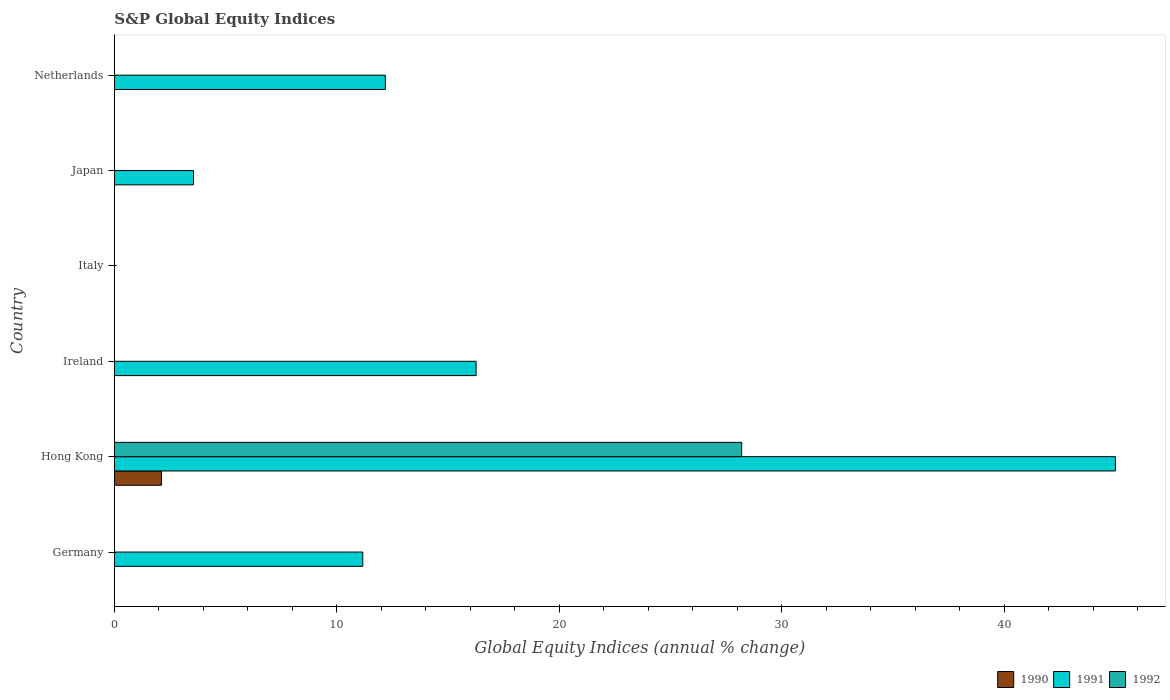How many different coloured bars are there?
Provide a succinct answer. 3. Are the number of bars on each tick of the Y-axis equal?
Offer a very short reply. No. How many bars are there on the 4th tick from the bottom?
Ensure brevity in your answer.  0. What is the label of the 5th group of bars from the top?
Your answer should be compact. Hong Kong. What is the global equity indices in 1992 in Japan?
Provide a succinct answer. 0. Across all countries, what is the maximum global equity indices in 1990?
Your answer should be compact. 2.11. In which country was the global equity indices in 1990 maximum?
Your answer should be very brief. Hong Kong. What is the total global equity indices in 1991 in the graph?
Keep it short and to the point. 88.14. What is the difference between the global equity indices in 1991 in Germany and that in Japan?
Keep it short and to the point. 7.61. What is the average global equity indices in 1992 per country?
Your response must be concise. 4.7. What is the difference between the global equity indices in 1992 and global equity indices in 1991 in Hong Kong?
Your answer should be very brief. -16.8. What is the difference between the highest and the second highest global equity indices in 1991?
Offer a terse response. 28.74. What is the difference between the highest and the lowest global equity indices in 1991?
Give a very brief answer. 44.99. Is the sum of the global equity indices in 1991 in Germany and Netherlands greater than the maximum global equity indices in 1990 across all countries?
Offer a terse response. Yes. Is it the case that in every country, the sum of the global equity indices in 1992 and global equity indices in 1990 is greater than the global equity indices in 1991?
Give a very brief answer. No. What is the difference between two consecutive major ticks on the X-axis?
Your response must be concise. 10. Are the values on the major ticks of X-axis written in scientific E-notation?
Your answer should be compact. No. Does the graph contain grids?
Make the answer very short. No. Where does the legend appear in the graph?
Offer a very short reply. Bottom right. How are the legend labels stacked?
Offer a terse response. Horizontal. What is the title of the graph?
Give a very brief answer. S&P Global Equity Indices. Does "2005" appear as one of the legend labels in the graph?
Provide a short and direct response. No. What is the label or title of the X-axis?
Offer a terse response. Global Equity Indices (annual % change). What is the Global Equity Indices (annual % change) in 1991 in Germany?
Make the answer very short. 11.16. What is the Global Equity Indices (annual % change) in 1990 in Hong Kong?
Provide a succinct answer. 2.11. What is the Global Equity Indices (annual % change) of 1991 in Hong Kong?
Offer a terse response. 44.99. What is the Global Equity Indices (annual % change) of 1992 in Hong Kong?
Provide a succinct answer. 28.19. What is the Global Equity Indices (annual % change) of 1990 in Ireland?
Your answer should be compact. 0. What is the Global Equity Indices (annual % change) of 1991 in Ireland?
Your answer should be compact. 16.26. What is the Global Equity Indices (annual % change) of 1992 in Ireland?
Offer a very short reply. 0. What is the Global Equity Indices (annual % change) of 1991 in Japan?
Offer a terse response. 3.55. What is the Global Equity Indices (annual % change) in 1992 in Japan?
Offer a terse response. 0. What is the Global Equity Indices (annual % change) in 1991 in Netherlands?
Your answer should be compact. 12.18. Across all countries, what is the maximum Global Equity Indices (annual % change) in 1990?
Give a very brief answer. 2.11. Across all countries, what is the maximum Global Equity Indices (annual % change) of 1991?
Your response must be concise. 44.99. Across all countries, what is the maximum Global Equity Indices (annual % change) of 1992?
Offer a very short reply. 28.19. Across all countries, what is the minimum Global Equity Indices (annual % change) of 1991?
Ensure brevity in your answer.  0. What is the total Global Equity Indices (annual % change) of 1990 in the graph?
Your answer should be very brief. 2.11. What is the total Global Equity Indices (annual % change) in 1991 in the graph?
Your answer should be compact. 88.14. What is the total Global Equity Indices (annual % change) of 1992 in the graph?
Provide a succinct answer. 28.19. What is the difference between the Global Equity Indices (annual % change) in 1991 in Germany and that in Hong Kong?
Your response must be concise. -33.83. What is the difference between the Global Equity Indices (annual % change) in 1991 in Germany and that in Ireland?
Provide a succinct answer. -5.09. What is the difference between the Global Equity Indices (annual % change) of 1991 in Germany and that in Japan?
Provide a short and direct response. 7.61. What is the difference between the Global Equity Indices (annual % change) in 1991 in Germany and that in Netherlands?
Make the answer very short. -1.01. What is the difference between the Global Equity Indices (annual % change) of 1991 in Hong Kong and that in Ireland?
Offer a very short reply. 28.74. What is the difference between the Global Equity Indices (annual % change) of 1991 in Hong Kong and that in Japan?
Your answer should be very brief. 41.44. What is the difference between the Global Equity Indices (annual % change) of 1991 in Hong Kong and that in Netherlands?
Give a very brief answer. 32.82. What is the difference between the Global Equity Indices (annual % change) in 1991 in Ireland and that in Japan?
Your answer should be very brief. 12.7. What is the difference between the Global Equity Indices (annual % change) of 1991 in Ireland and that in Netherlands?
Provide a succinct answer. 4.08. What is the difference between the Global Equity Indices (annual % change) in 1991 in Japan and that in Netherlands?
Keep it short and to the point. -8.62. What is the difference between the Global Equity Indices (annual % change) in 1991 in Germany and the Global Equity Indices (annual % change) in 1992 in Hong Kong?
Offer a very short reply. -17.03. What is the difference between the Global Equity Indices (annual % change) in 1990 in Hong Kong and the Global Equity Indices (annual % change) in 1991 in Ireland?
Your answer should be compact. -14.14. What is the difference between the Global Equity Indices (annual % change) in 1990 in Hong Kong and the Global Equity Indices (annual % change) in 1991 in Japan?
Provide a short and direct response. -1.44. What is the difference between the Global Equity Indices (annual % change) in 1990 in Hong Kong and the Global Equity Indices (annual % change) in 1991 in Netherlands?
Your response must be concise. -10.06. What is the average Global Equity Indices (annual % change) in 1990 per country?
Your response must be concise. 0.35. What is the average Global Equity Indices (annual % change) in 1991 per country?
Offer a very short reply. 14.69. What is the average Global Equity Indices (annual % change) of 1992 per country?
Your answer should be very brief. 4.7. What is the difference between the Global Equity Indices (annual % change) in 1990 and Global Equity Indices (annual % change) in 1991 in Hong Kong?
Your answer should be very brief. -42.88. What is the difference between the Global Equity Indices (annual % change) of 1990 and Global Equity Indices (annual % change) of 1992 in Hong Kong?
Make the answer very short. -26.08. What is the difference between the Global Equity Indices (annual % change) in 1991 and Global Equity Indices (annual % change) in 1992 in Hong Kong?
Ensure brevity in your answer.  16.8. What is the ratio of the Global Equity Indices (annual % change) of 1991 in Germany to that in Hong Kong?
Keep it short and to the point. 0.25. What is the ratio of the Global Equity Indices (annual % change) of 1991 in Germany to that in Ireland?
Make the answer very short. 0.69. What is the ratio of the Global Equity Indices (annual % change) in 1991 in Germany to that in Japan?
Offer a terse response. 3.14. What is the ratio of the Global Equity Indices (annual % change) of 1991 in Germany to that in Netherlands?
Provide a succinct answer. 0.92. What is the ratio of the Global Equity Indices (annual % change) in 1991 in Hong Kong to that in Ireland?
Your response must be concise. 2.77. What is the ratio of the Global Equity Indices (annual % change) of 1991 in Hong Kong to that in Japan?
Provide a short and direct response. 12.66. What is the ratio of the Global Equity Indices (annual % change) in 1991 in Hong Kong to that in Netherlands?
Ensure brevity in your answer.  3.69. What is the ratio of the Global Equity Indices (annual % change) in 1991 in Ireland to that in Japan?
Offer a terse response. 4.57. What is the ratio of the Global Equity Indices (annual % change) in 1991 in Ireland to that in Netherlands?
Your answer should be compact. 1.34. What is the ratio of the Global Equity Indices (annual % change) of 1991 in Japan to that in Netherlands?
Offer a very short reply. 0.29. What is the difference between the highest and the second highest Global Equity Indices (annual % change) of 1991?
Give a very brief answer. 28.74. What is the difference between the highest and the lowest Global Equity Indices (annual % change) of 1990?
Provide a short and direct response. 2.11. What is the difference between the highest and the lowest Global Equity Indices (annual % change) of 1991?
Offer a very short reply. 44.99. What is the difference between the highest and the lowest Global Equity Indices (annual % change) of 1992?
Provide a short and direct response. 28.19. 